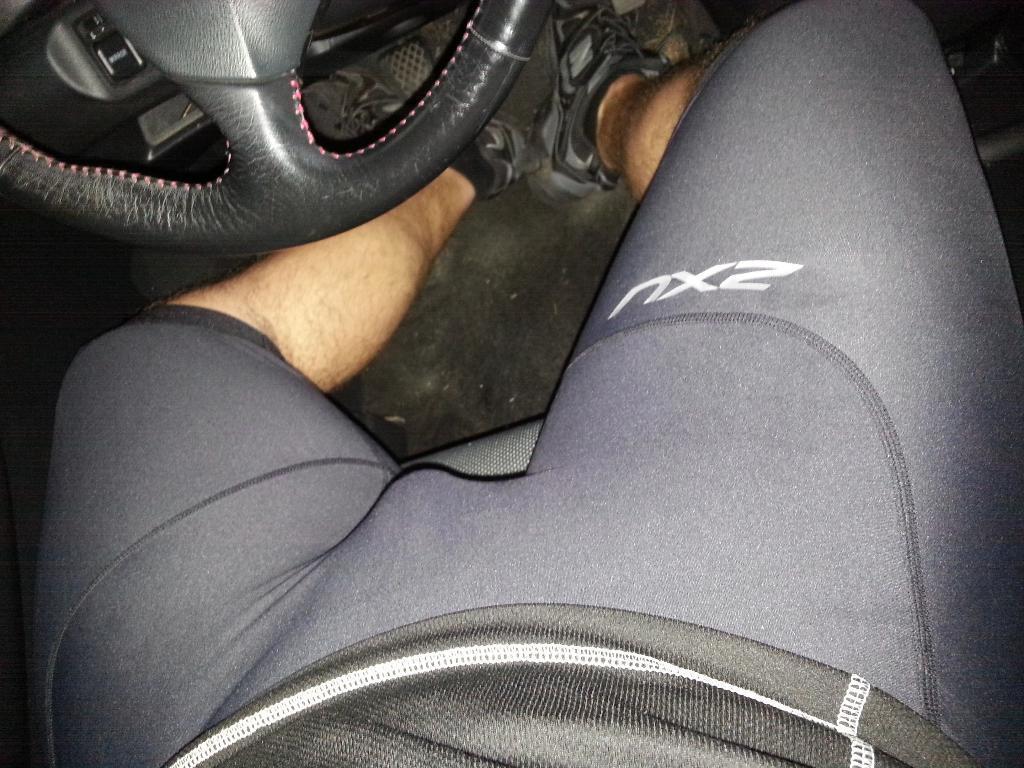How would you summarize this image in a sentence or two? In this picture we can see a person is seated in the car, in the top left hand corner we can see steering wheel. 